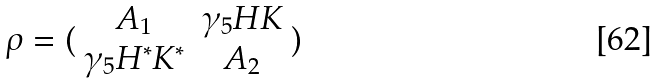Convert formula to latex. <formula><loc_0><loc_0><loc_500><loc_500>\rho = ( \begin{array} { c c } A _ { 1 } & \gamma _ { 5 } H K \\ \gamma _ { 5 } H ^ { * } K ^ { * } & A _ { 2 } \end{array} )</formula> 